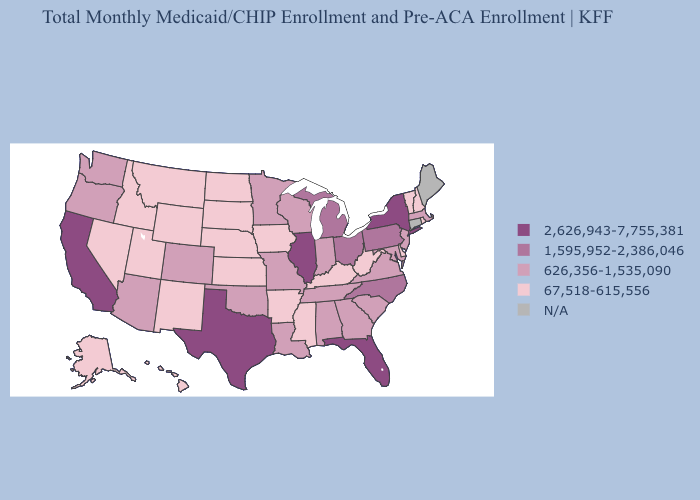What is the lowest value in the South?
Be succinct. 67,518-615,556. Among the states that border Georgia , does North Carolina have the highest value?
Concise answer only. No. Does West Virginia have the lowest value in the South?
Write a very short answer. Yes. Among the states that border Mississippi , which have the highest value?
Keep it brief. Alabama, Louisiana, Tennessee. What is the value of Florida?
Give a very brief answer. 2,626,943-7,755,381. How many symbols are there in the legend?
Write a very short answer. 5. Which states have the highest value in the USA?
Give a very brief answer. California, Florida, Illinois, New York, Texas. Name the states that have a value in the range 626,356-1,535,090?
Concise answer only. Alabama, Arizona, Colorado, Georgia, Indiana, Louisiana, Maryland, Massachusetts, Minnesota, Missouri, New Jersey, Oklahoma, Oregon, South Carolina, Tennessee, Virginia, Washington, Wisconsin. What is the lowest value in the USA?
Give a very brief answer. 67,518-615,556. What is the value of Arkansas?
Answer briefly. 67,518-615,556. What is the lowest value in states that border Alabama?
Keep it brief. 67,518-615,556. Does Illinois have the highest value in the USA?
Write a very short answer. Yes. Name the states that have a value in the range 2,626,943-7,755,381?
Answer briefly. California, Florida, Illinois, New York, Texas. Among the states that border Arkansas , does Louisiana have the highest value?
Be succinct. No. What is the highest value in the USA?
Be succinct. 2,626,943-7,755,381. 